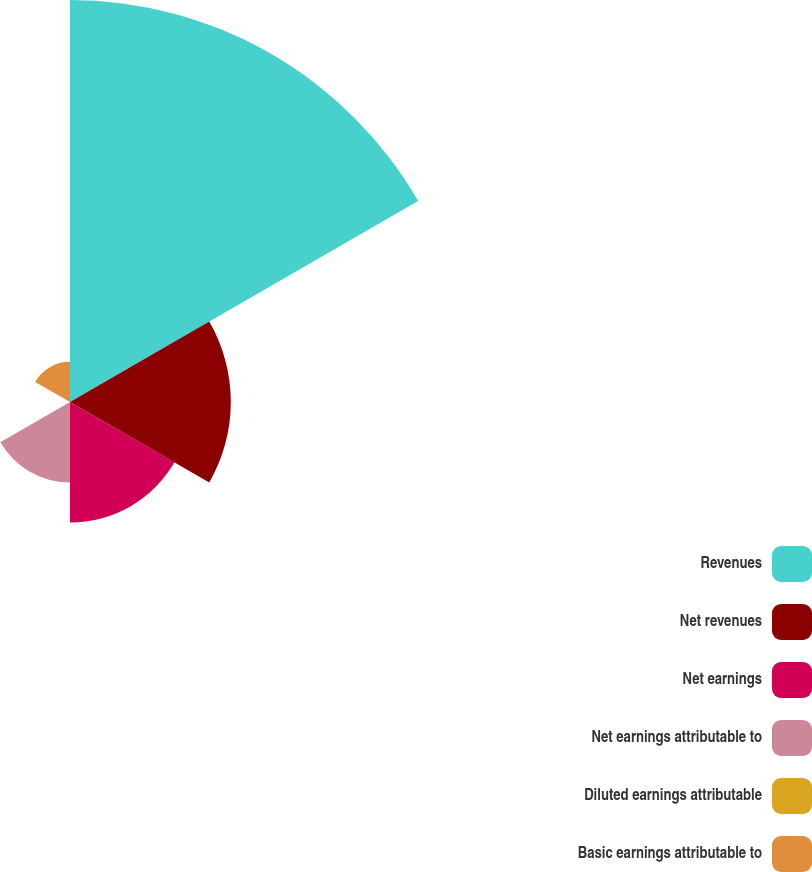Convert chart. <chart><loc_0><loc_0><loc_500><loc_500><pie_chart><fcel>Revenues<fcel>Net revenues<fcel>Net earnings<fcel>Net earnings attributable to<fcel>Diluted earnings attributable<fcel>Basic earnings attributable to<nl><fcel>50.0%<fcel>20.0%<fcel>15.0%<fcel>10.0%<fcel>0.0%<fcel>5.0%<nl></chart> 